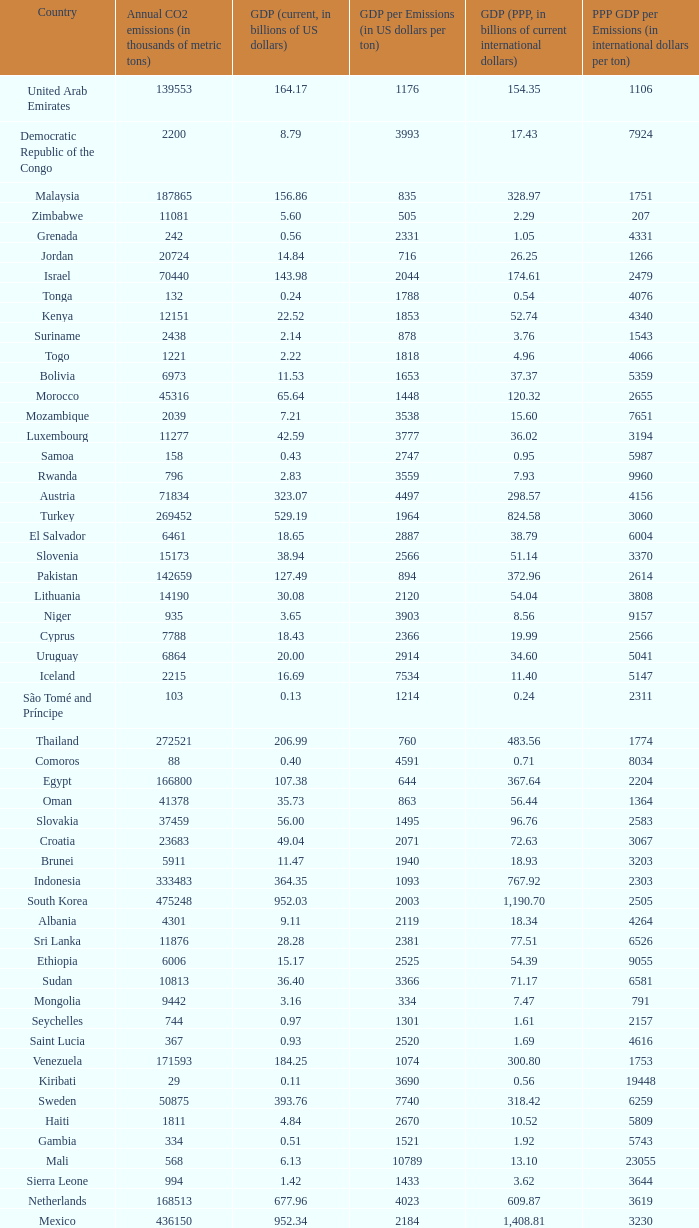When the gdp (current, in billions of us dollars) is 162.50, what is the gdp? 2562.0. 